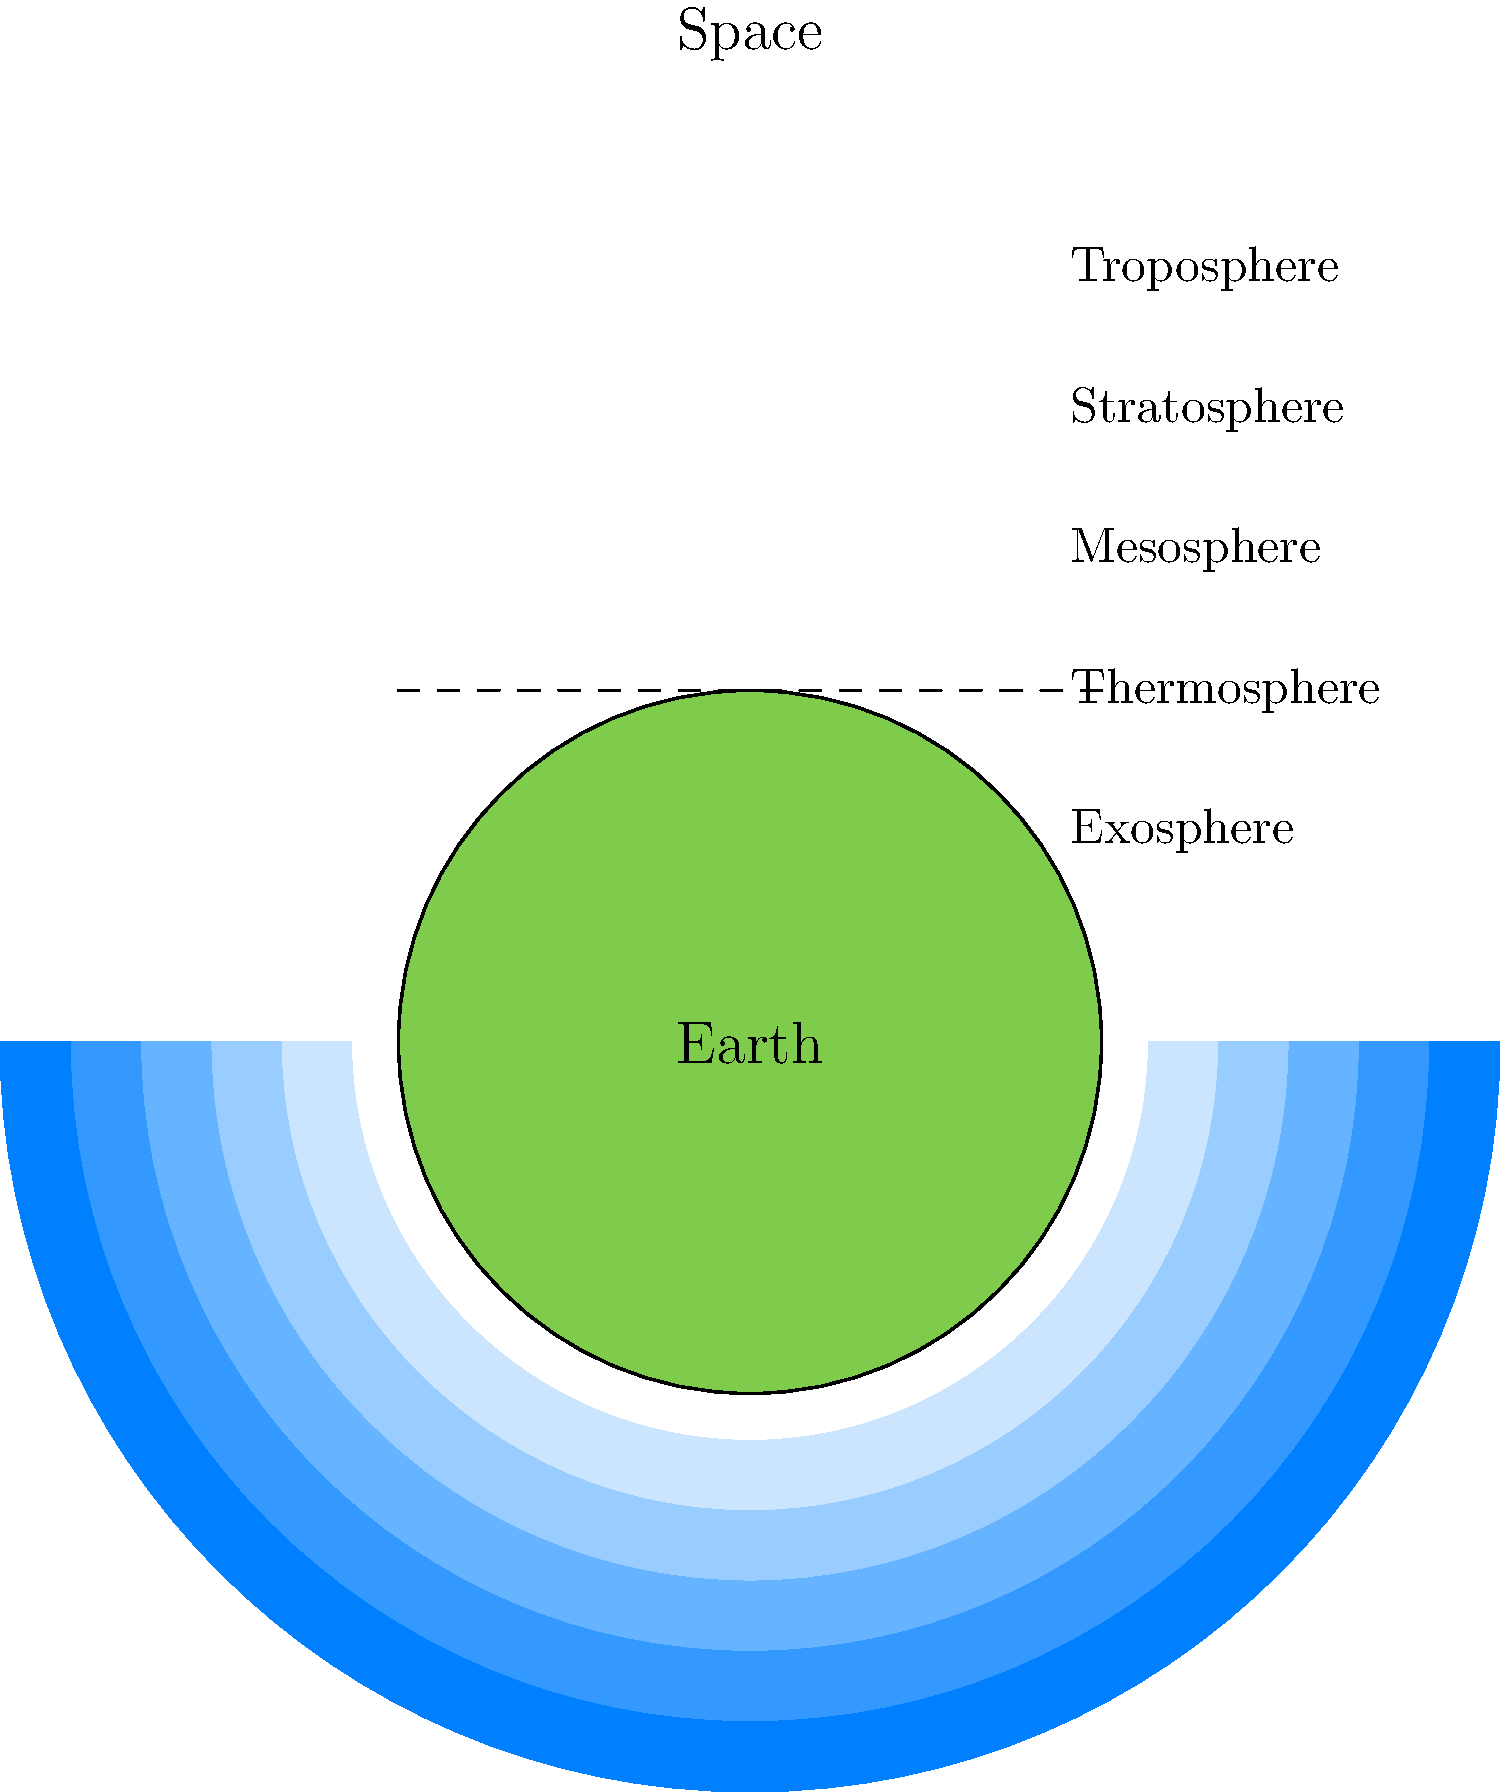As a motion graphic artist working on a horror-themed educational video about Earth's atmosphere, you need to create a cross-sectional diagram of the atmospheric layers. Which layer should you depict as the thickest and most vibrant to emphasize its significance in protecting life on Earth from harmful radiation? To answer this question, let's examine the layers of Earth's atmosphere from bottom to top:

1. Troposphere: The lowest layer, where weather occurs and most life exists.
2. Stratosphere: Contains the ozone layer, which absorbs harmful UV radiation.
3. Mesosphere: Where meteors burn up upon entering Earth's atmosphere.
4. Thermosphere: Contains the ionosphere, important for radio communication.
5. Exosphere: The outermost layer, transitioning into space.

For a horror-themed educational video emphasizing protection from harmful radiation, the stratosphere should be highlighted because:

1. It contains the ozone layer, which absorbs 97-99% of the Sun's harmful ultraviolet (UV) radiation.
2. Without the ozone layer, life on Earth would be severely damaged or impossible due to excessive UV exposure.
3. The stratosphere is relatively thick, extending from about 10 km to 50 km above Earth's surface.
4. Its protective role aligns well with horror themes, as it shields us from the "horrors" of space radiation.

By depicting the stratosphere as the thickest and most vibrant layer, you can effectively communicate its crucial role in protecting life on Earth while maintaining the horror theme of your educational video.
Answer: Stratosphere 